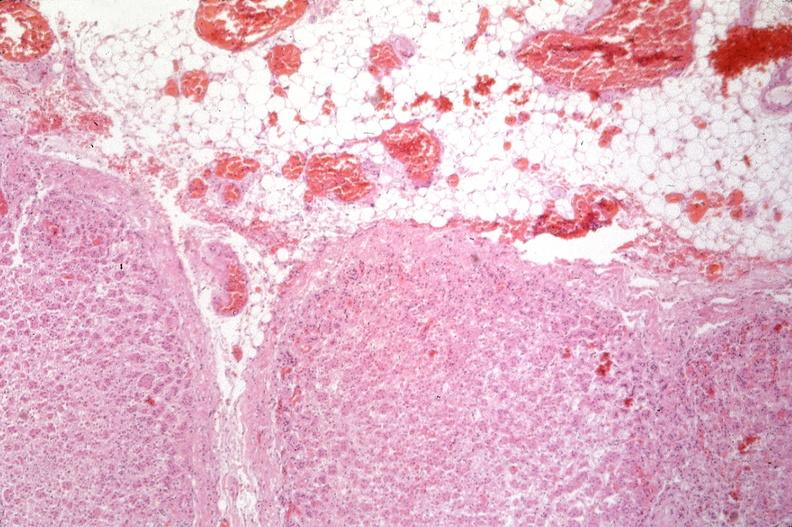does this image show pancreas, thrombi and hemorrhage due to disseminated intravascular coagulation dic?
Answer the question using a single word or phrase. Yes 